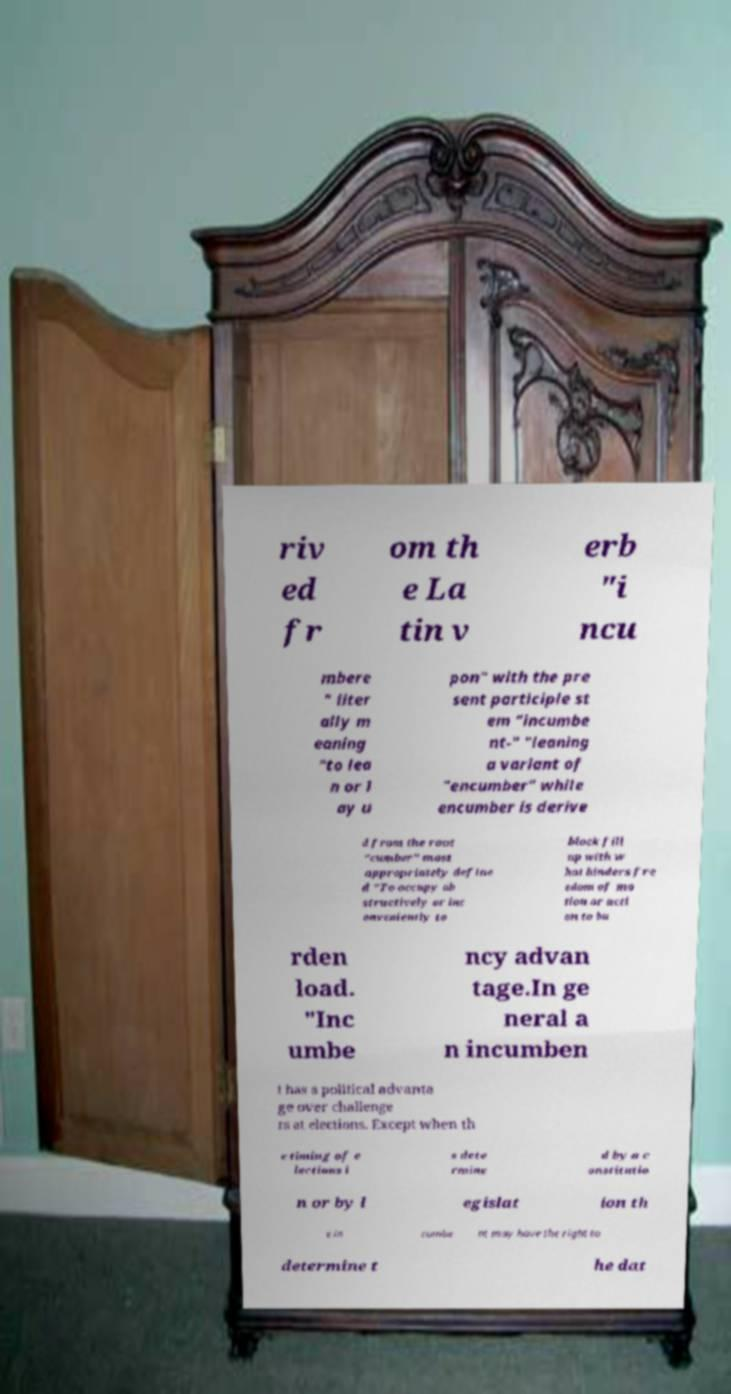I need the written content from this picture converted into text. Can you do that? riv ed fr om th e La tin v erb "i ncu mbere " liter ally m eaning "to lea n or l ay u pon" with the pre sent participle st em "incumbe nt-" "leaning a variant of "encumber" while encumber is derive d from the root "cumber" most appropriately define d "To occupy ob structively or inc onveniently to block fill up with w hat hinders fre edom of mo tion or acti on to bu rden load. "Inc umbe ncy advan tage.In ge neral a n incumben t has a political advanta ge over challenge rs at elections. Except when th e timing of e lections i s dete rmine d by a c onstitutio n or by l egislat ion th e in cumbe nt may have the right to determine t he dat 